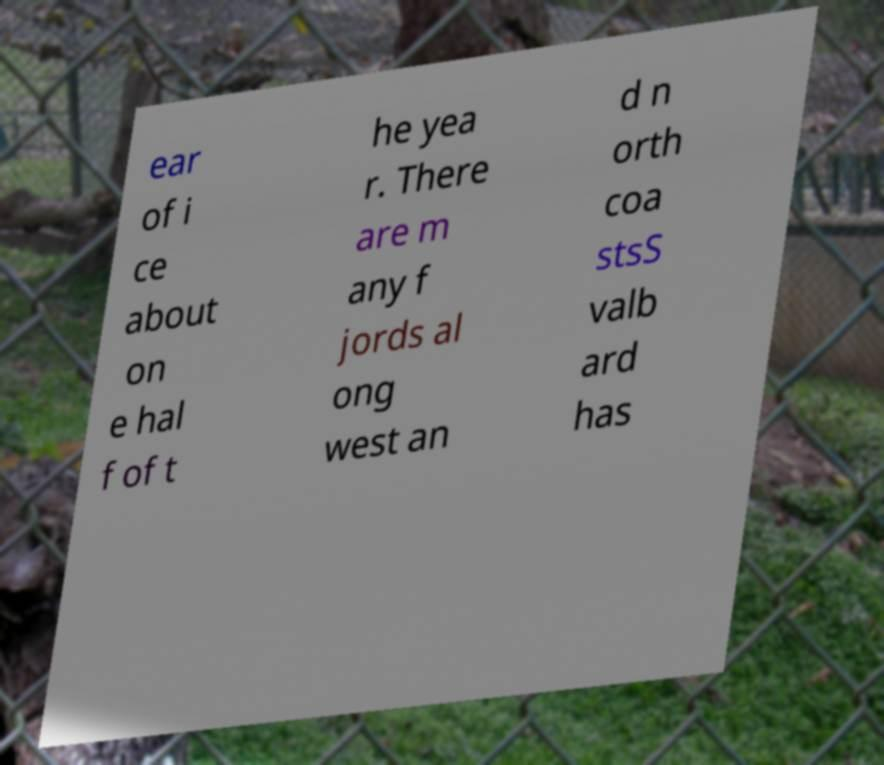There's text embedded in this image that I need extracted. Can you transcribe it verbatim? ear of i ce about on e hal f of t he yea r. There are m any f jords al ong west an d n orth coa stsS valb ard has 